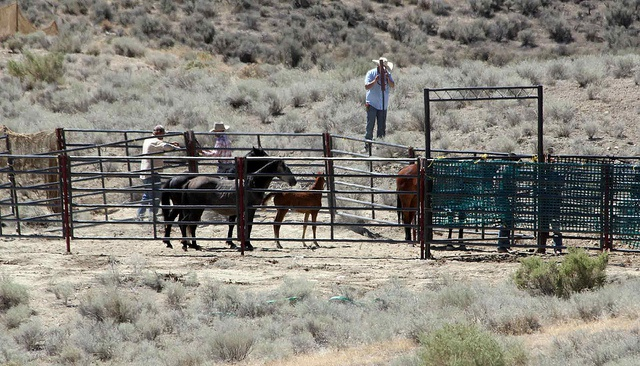Describe the objects in this image and their specific colors. I can see horse in black, gray, and darkgray tones, horse in black, teal, darkblue, and gray tones, horse in black, gray, darkgray, and lightgray tones, horse in black, maroon, gray, and darkgray tones, and people in black, gray, teal, and darkblue tones in this image. 